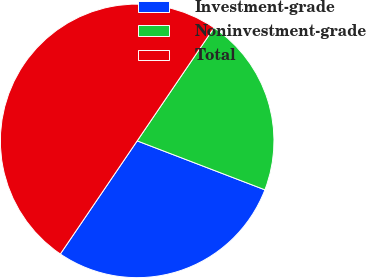<chart> <loc_0><loc_0><loc_500><loc_500><pie_chart><fcel>Investment-grade<fcel>Noninvestment-grade<fcel>Total<nl><fcel>28.67%<fcel>21.33%<fcel>50.0%<nl></chart> 